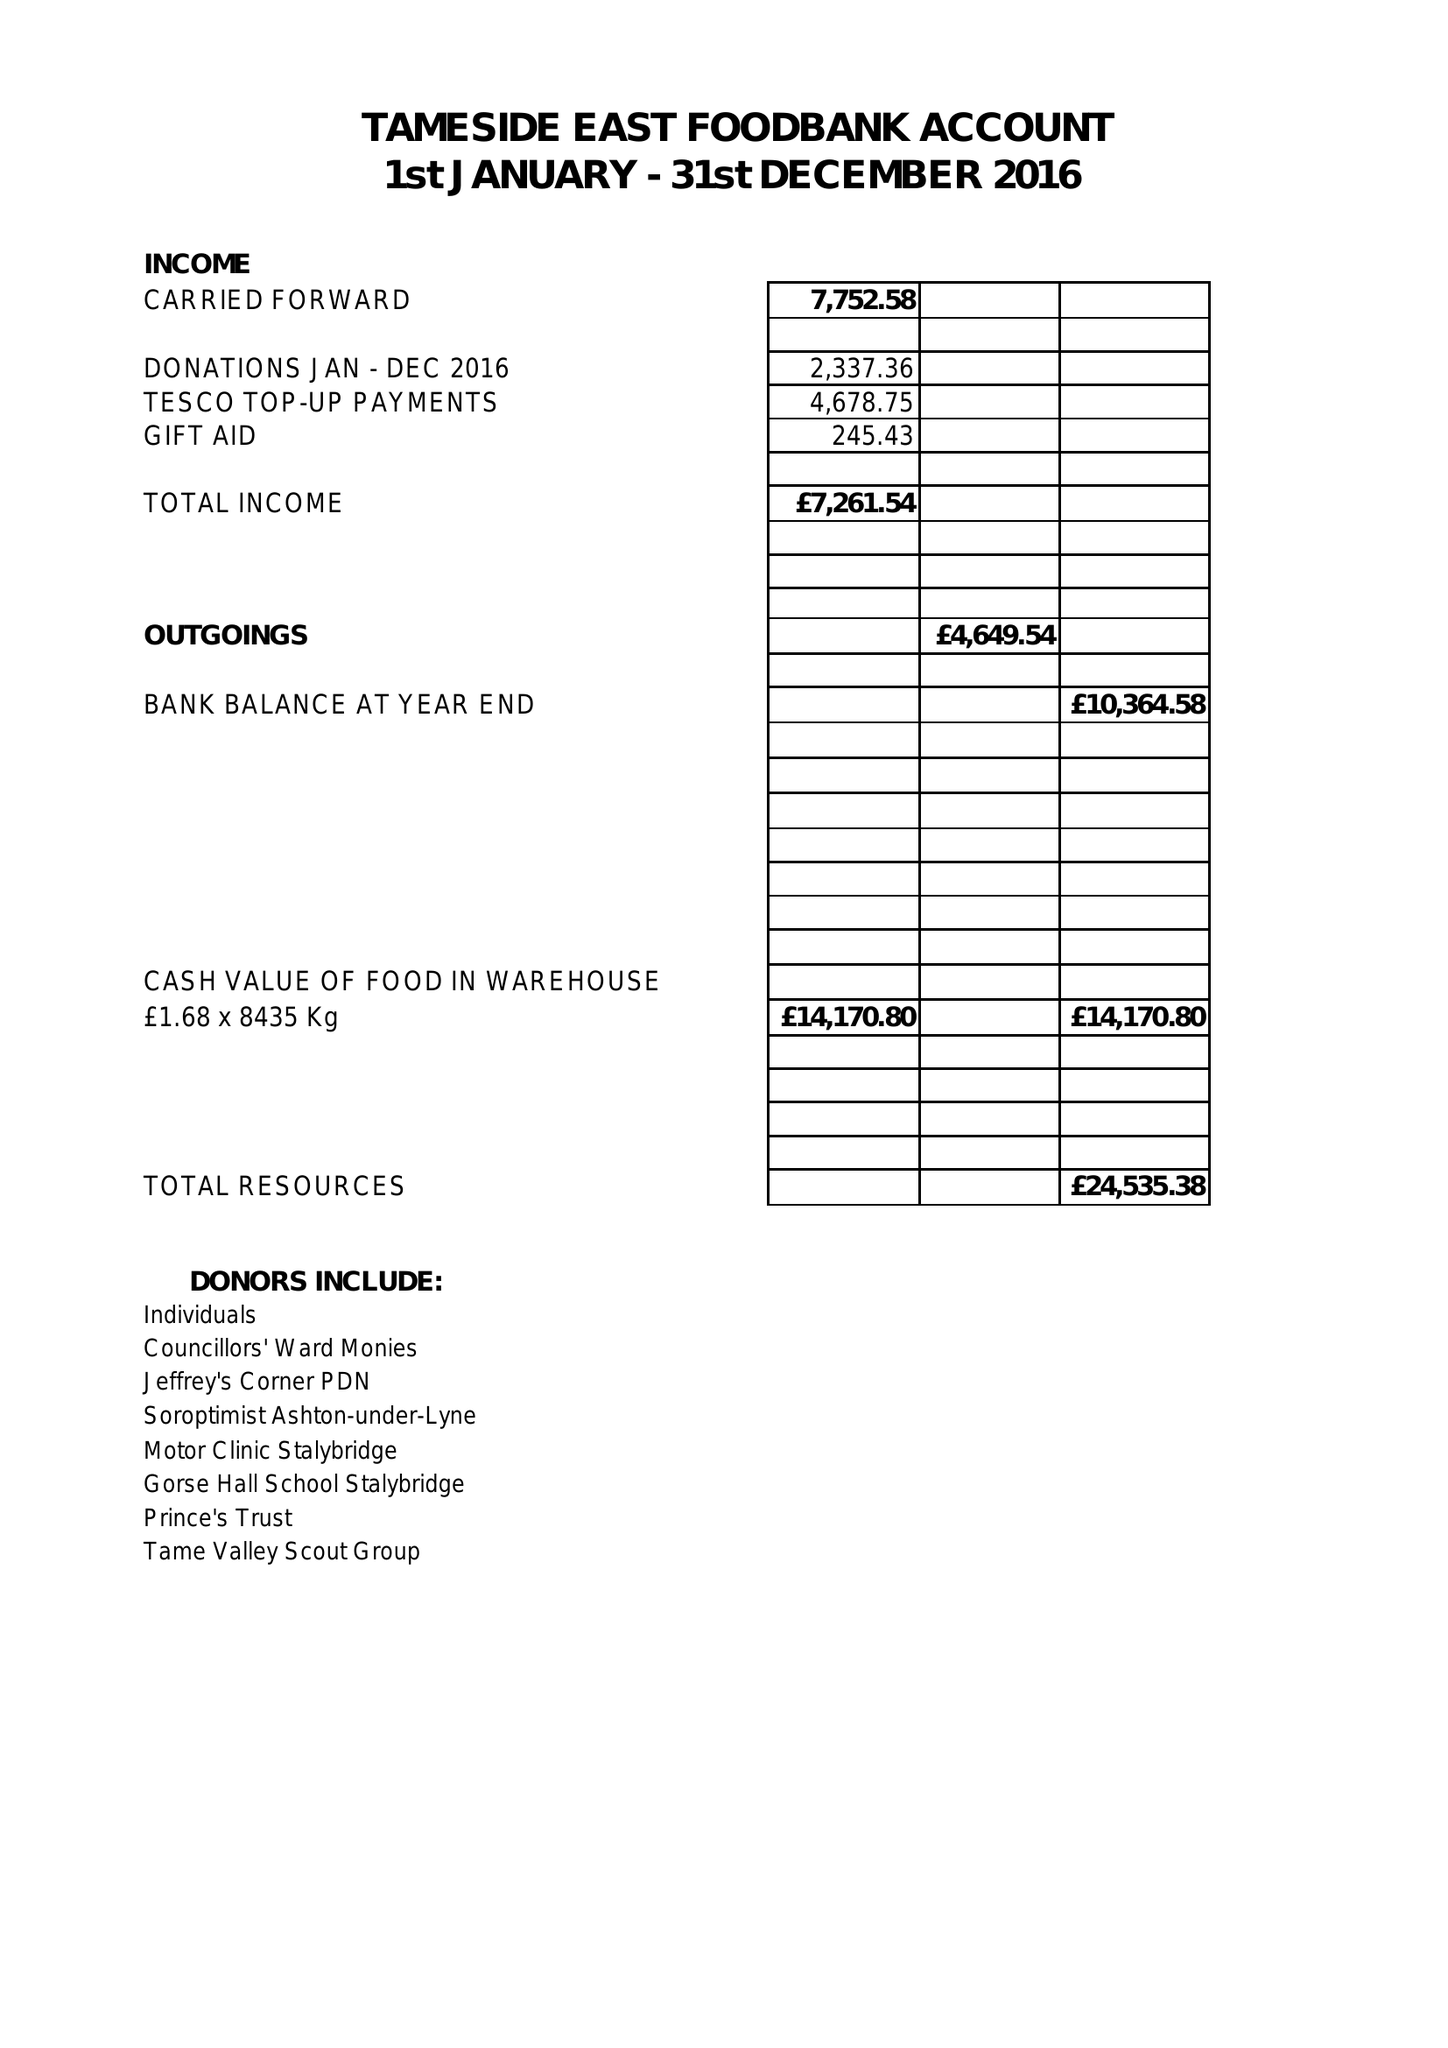What is the value for the address__post_town?
Answer the question using a single word or phrase. STALYBRIDGE 